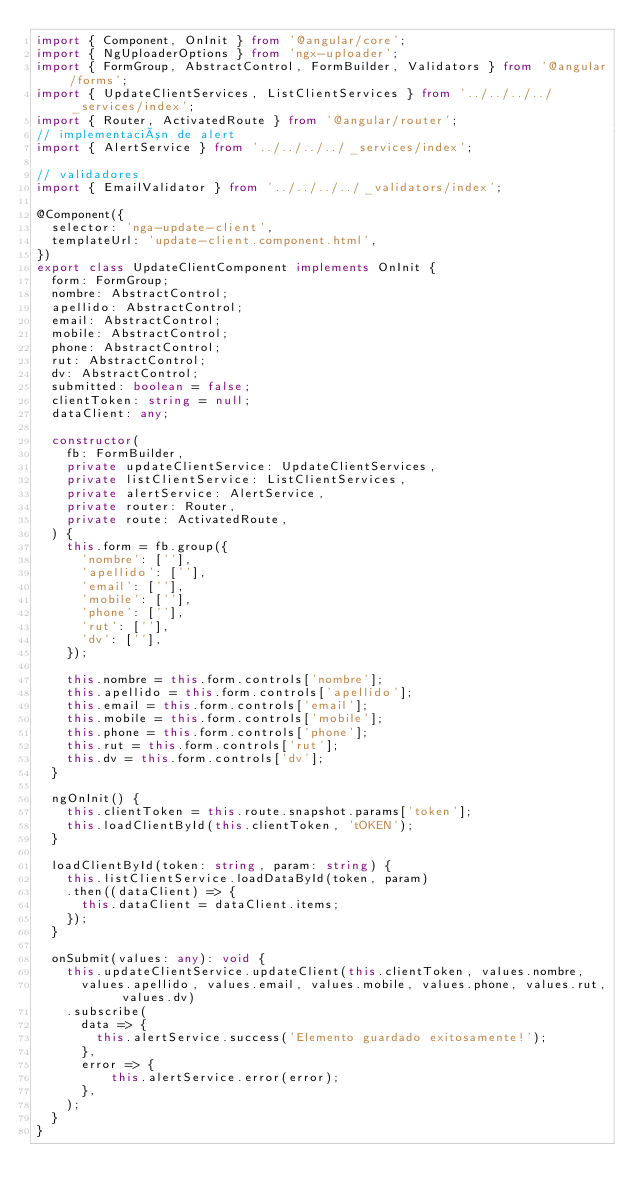<code> <loc_0><loc_0><loc_500><loc_500><_TypeScript_>import { Component, OnInit } from '@angular/core';
import { NgUploaderOptions } from 'ngx-uploader';
import { FormGroup, AbstractControl, FormBuilder, Validators } from '@angular/forms';
import { UpdateClientServices, ListClientServices } from '../../../../_services/index';
import { Router, ActivatedRoute } from '@angular/router';
// implementación de alert
import { AlertService } from '../../../../_services/index';

// validadores
import { EmailValidator } from '../../../../_validators/index';

@Component({
  selector: 'nga-update-client',
  templateUrl: 'update-client.component.html',
})
export class UpdateClientComponent implements OnInit {
  form: FormGroup;
  nombre: AbstractControl;
  apellido: AbstractControl;
  email: AbstractControl;
  mobile: AbstractControl;
  phone: AbstractControl;
  rut: AbstractControl;
  dv: AbstractControl;
  submitted: boolean = false;
  clientToken: string = null;
  dataClient: any;

  constructor(
    fb: FormBuilder,
    private updateClientService: UpdateClientServices,
    private listClientService: ListClientServices,
    private alertService: AlertService,
    private router: Router,
    private route: ActivatedRoute,
  ) {
    this.form = fb.group({
      'nombre': [''],
      'apellido': [''],
      'email': [''],
      'mobile': [''],
      'phone': [''],
      'rut': [''],
      'dv': [''],
    });

    this.nombre = this.form.controls['nombre'];
    this.apellido = this.form.controls['apellido'];
    this.email = this.form.controls['email'];
    this.mobile = this.form.controls['mobile'];
    this.phone = this.form.controls['phone'];
    this.rut = this.form.controls['rut'];
    this.dv = this.form.controls['dv'];
  }

  ngOnInit() {
    this.clientToken = this.route.snapshot.params['token'];
    this.loadClientById(this.clientToken, 'tOKEN');
  }

  loadClientById(token: string, param: string) {
    this.listClientService.loadDataById(token, param)
    .then((dataClient) => {
      this.dataClient = dataClient.items;
    });
  }

  onSubmit(values: any): void {
    this.updateClientService.updateClient(this.clientToken, values.nombre,
      values.apellido, values.email, values.mobile, values.phone, values.rut, values.dv)
    .subscribe(
      data => {
        this.alertService.success('Elemento guardado exitosamente!');
      },
      error => {
          this.alertService.error(error);
      },
    );
  }
}
</code> 